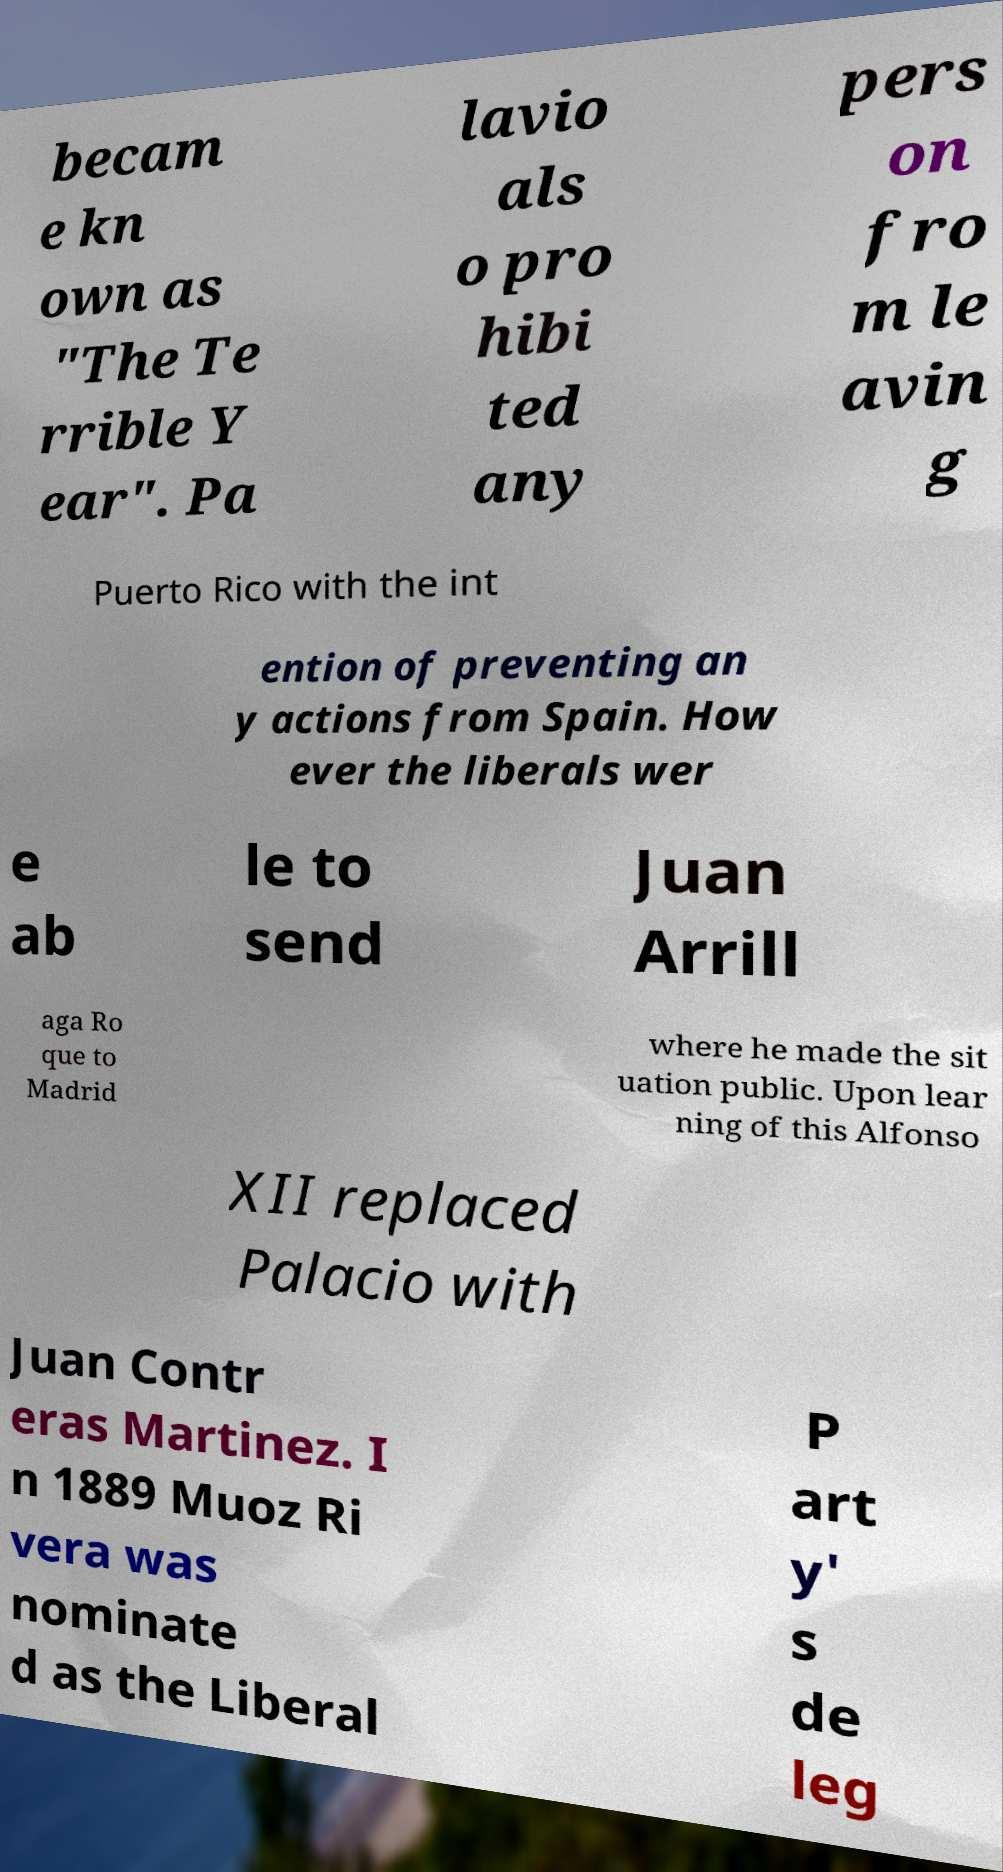For documentation purposes, I need the text within this image transcribed. Could you provide that? becam e kn own as "The Te rrible Y ear". Pa lavio als o pro hibi ted any pers on fro m le avin g Puerto Rico with the int ention of preventing an y actions from Spain. How ever the liberals wer e ab le to send Juan Arrill aga Ro que to Madrid where he made the sit uation public. Upon lear ning of this Alfonso XII replaced Palacio with Juan Contr eras Martinez. I n 1889 Muoz Ri vera was nominate d as the Liberal P art y' s de leg 